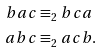Convert formula to latex. <formula><loc_0><loc_0><loc_500><loc_500>b a c & \equiv _ { 2 } b c a \\ a b c & \equiv _ { 2 } a c b .</formula> 